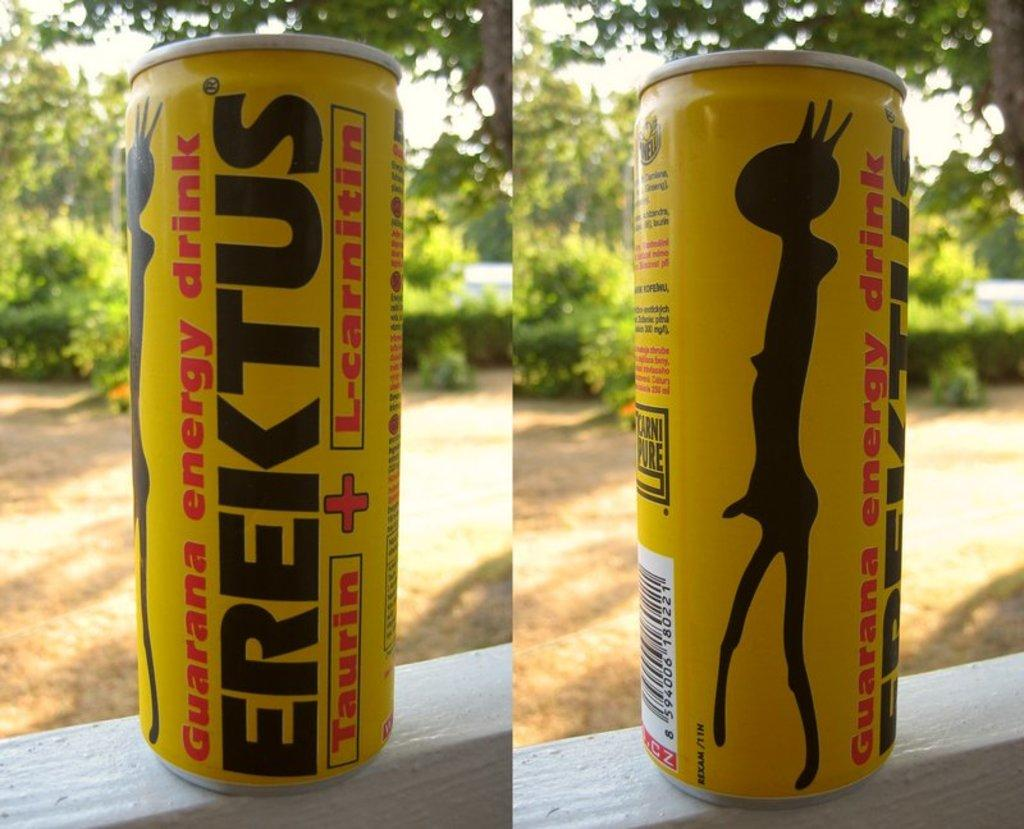<image>
Provide a brief description of the given image. Two pics of a can of energy drink called Erektus. 